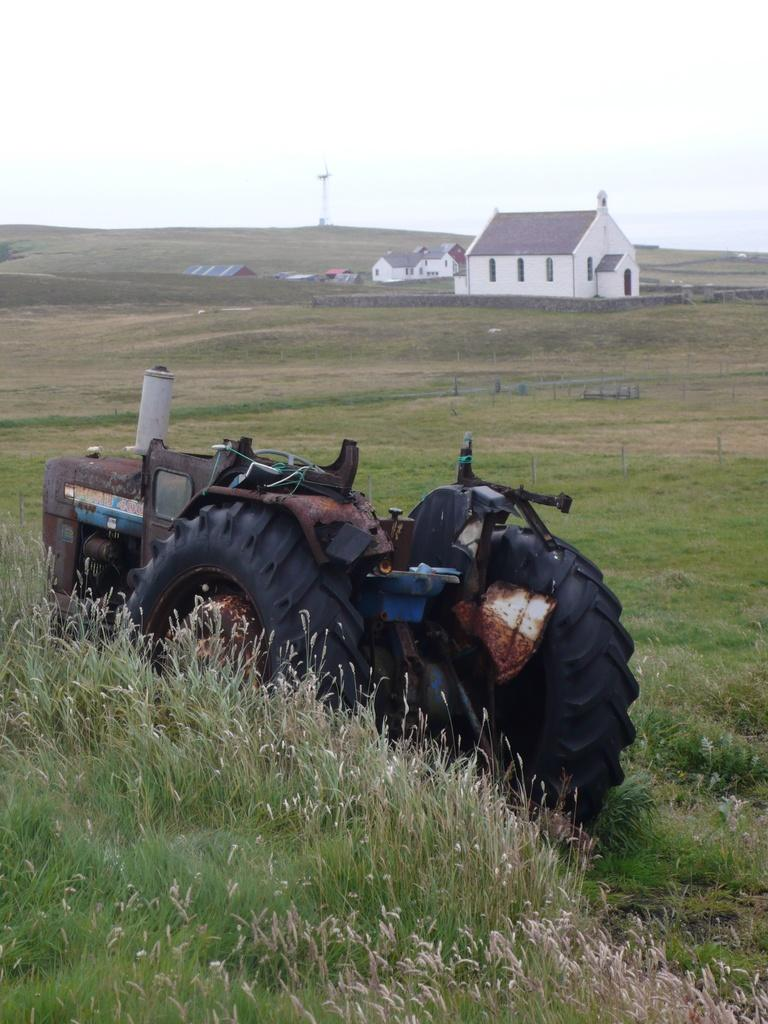What type of vehicle is on the ground in the image? A: There is a vehicle on the ground in the image, but the specific type is not mentioned. What type of vegetation is visible in the image? There is grass visible in the image. What structures can be seen in the image? There are houses in the image. What is the tall, vertical object in the image? There is a pole in the image. What is visible in the background of the image? The sky is visible in the background of the image. Can you hear the person coughing in the image? There is no sound or audio in the image, so it is not possible to hear anyone coughing. What color is the person's lipstick in the image? There are no people or lips present in the image, so it is not possible to determine the color of anyone's lipstick. 